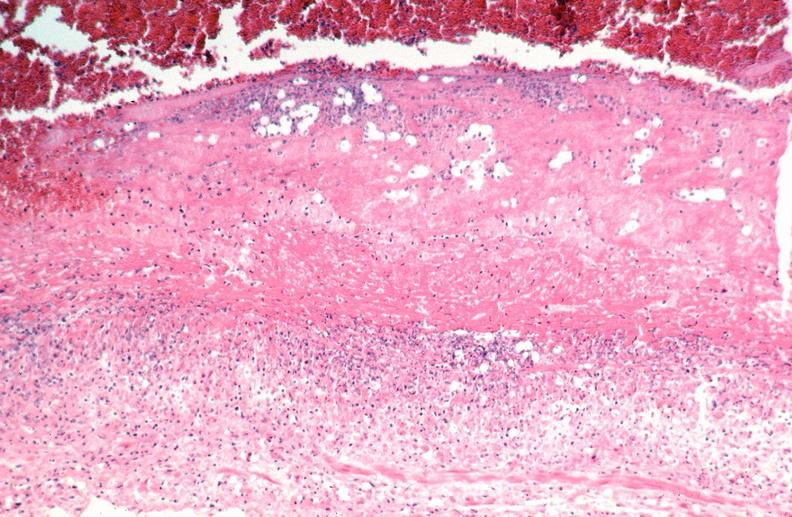does breast show vasculitis, polyarteritis nodosa?
Answer the question using a single word or phrase. No 